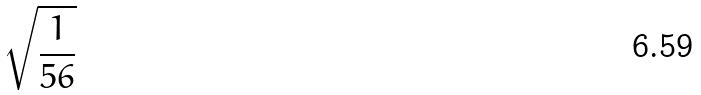Convert formula to latex. <formula><loc_0><loc_0><loc_500><loc_500>\sqrt { \frac { 1 } { 5 6 } }</formula> 